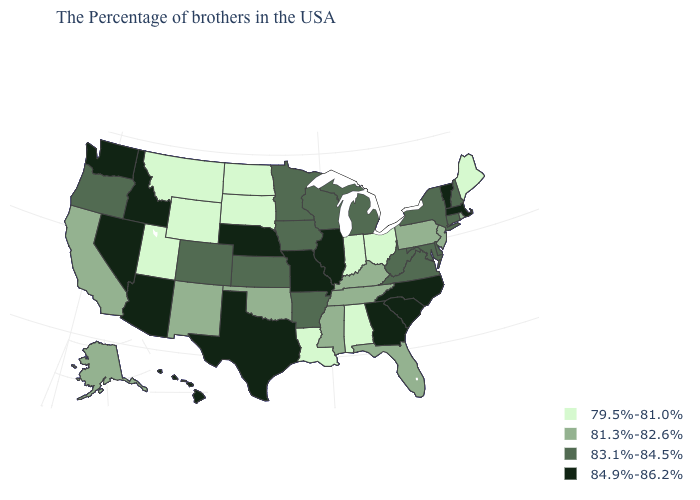Name the states that have a value in the range 79.5%-81.0%?
Give a very brief answer. Maine, Ohio, Indiana, Alabama, Louisiana, South Dakota, North Dakota, Wyoming, Utah, Montana. Does the map have missing data?
Quick response, please. No. What is the value of New Mexico?
Be succinct. 81.3%-82.6%. What is the lowest value in the MidWest?
Be succinct. 79.5%-81.0%. What is the lowest value in the USA?
Keep it brief. 79.5%-81.0%. What is the lowest value in the USA?
Keep it brief. 79.5%-81.0%. Does Connecticut have the same value as Maryland?
Concise answer only. Yes. What is the value of Georgia?
Answer briefly. 84.9%-86.2%. How many symbols are there in the legend?
Keep it brief. 4. Which states have the highest value in the USA?
Quick response, please. Massachusetts, Vermont, North Carolina, South Carolina, Georgia, Illinois, Missouri, Nebraska, Texas, Arizona, Idaho, Nevada, Washington, Hawaii. What is the value of Georgia?
Write a very short answer. 84.9%-86.2%. Does Alabama have the highest value in the USA?
Give a very brief answer. No. Is the legend a continuous bar?
Answer briefly. No. Which states have the lowest value in the Northeast?
Be succinct. Maine. Name the states that have a value in the range 84.9%-86.2%?
Write a very short answer. Massachusetts, Vermont, North Carolina, South Carolina, Georgia, Illinois, Missouri, Nebraska, Texas, Arizona, Idaho, Nevada, Washington, Hawaii. 